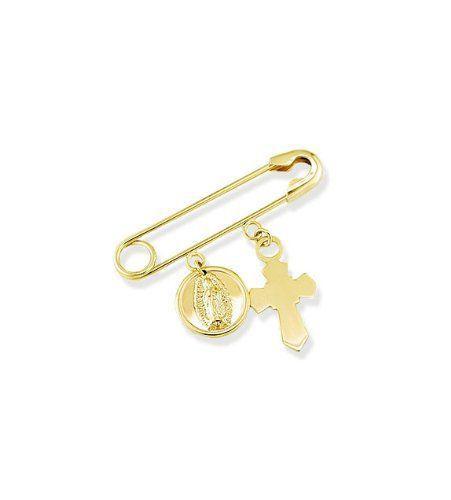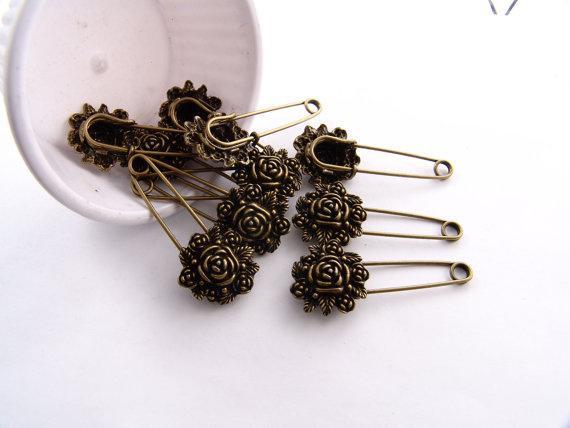The first image is the image on the left, the second image is the image on the right. For the images displayed, is the sentence "There is a feather in one of the images." factually correct? Answer yes or no. No. 